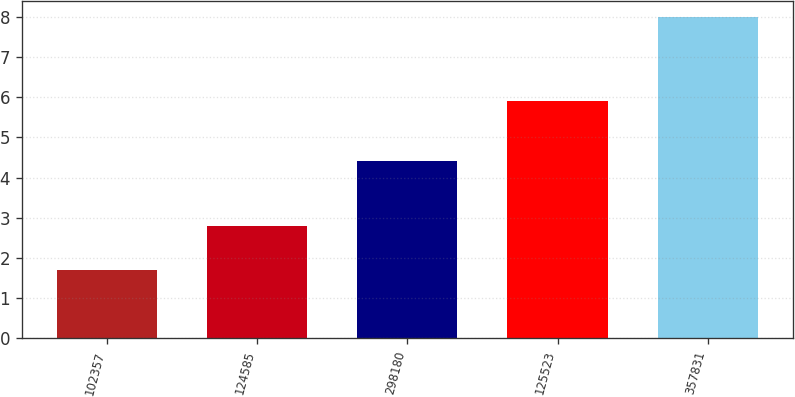Convert chart to OTSL. <chart><loc_0><loc_0><loc_500><loc_500><bar_chart><fcel>102357<fcel>124585<fcel>298180<fcel>125523<fcel>357831<nl><fcel>1.7<fcel>2.8<fcel>4.4<fcel>5.9<fcel>8<nl></chart> 